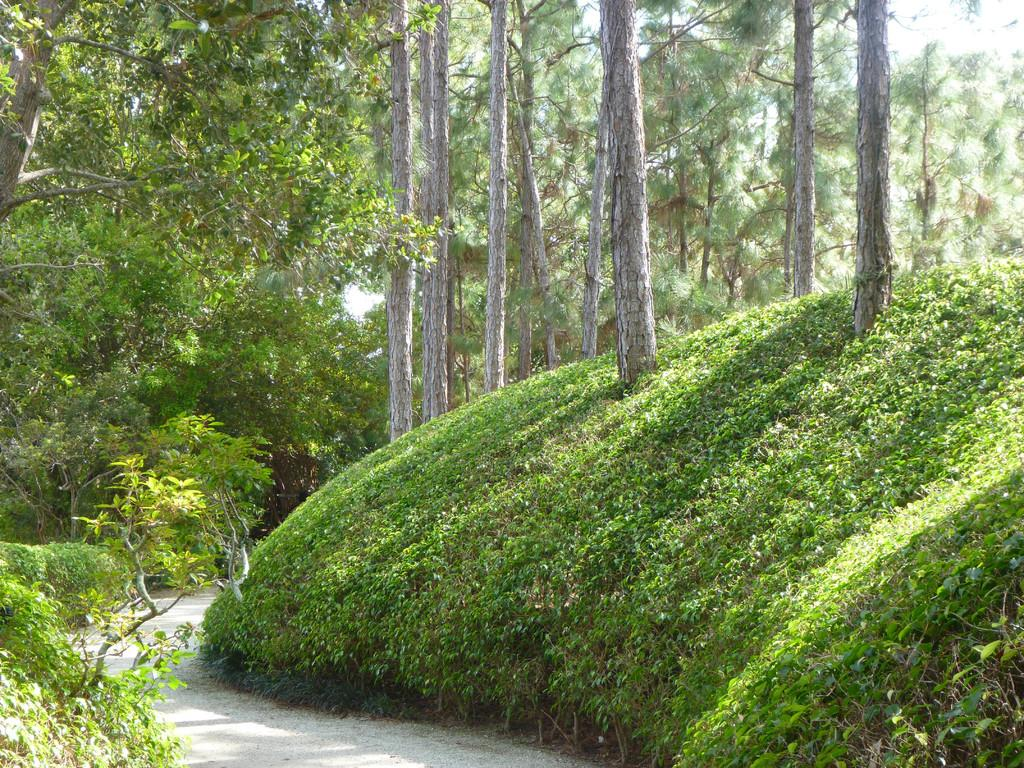What type of vegetation can be seen in the image? There are trees in the image. What else can be seen on the ground in the image? There is grass in the image. What type of pathway is present in the image? There is a road in the image. What is visible above the ground in the image? The sky is visible in the image. Can you see a yoke being used by the trees in the image? There is no yoke present in the image, and trees do not use yokes. What time does the watch in the image show? There is no watch present in the image. 